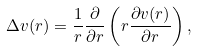<formula> <loc_0><loc_0><loc_500><loc_500>\Delta v ( r ) = \frac { 1 } { r } \frac { \partial } { \partial r } \left ( r \frac { \partial v ( r ) } { \partial r } \right ) ,</formula> 